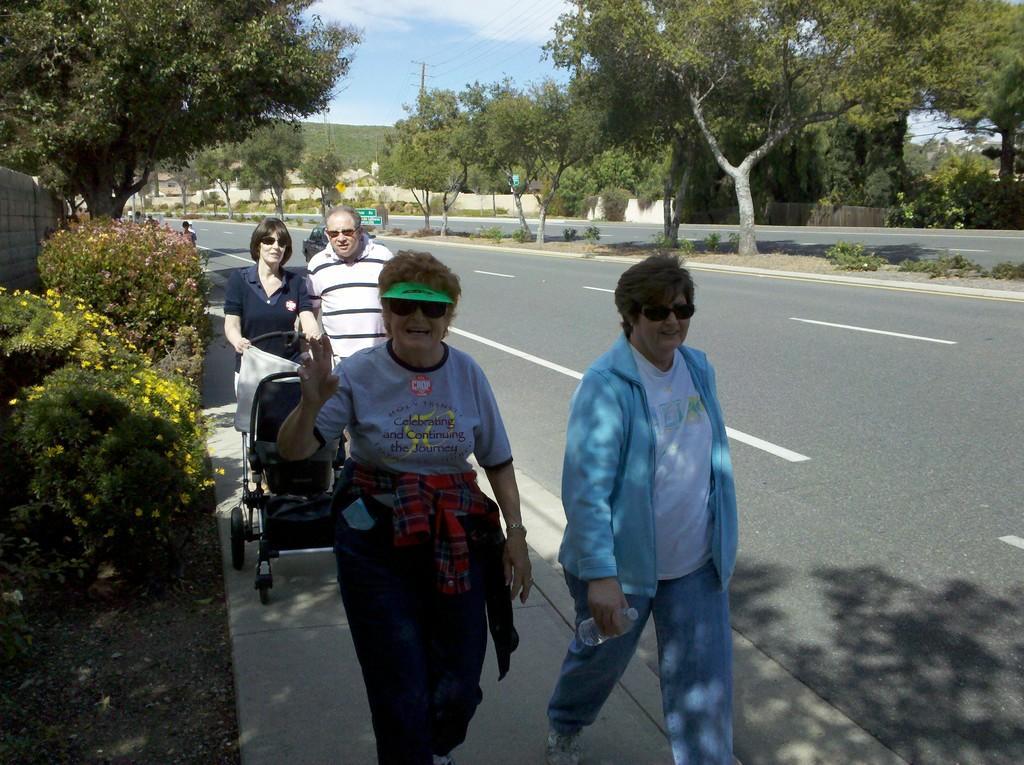How would you summarize this image in a sentence or two? In this image I can see few people are standing in the front and I can see all of them are wearing black shades. In the center of this image I can see few roads and both side of it I can see number of trees. In the background I can see a pole, few wires, clouds and the sky. 